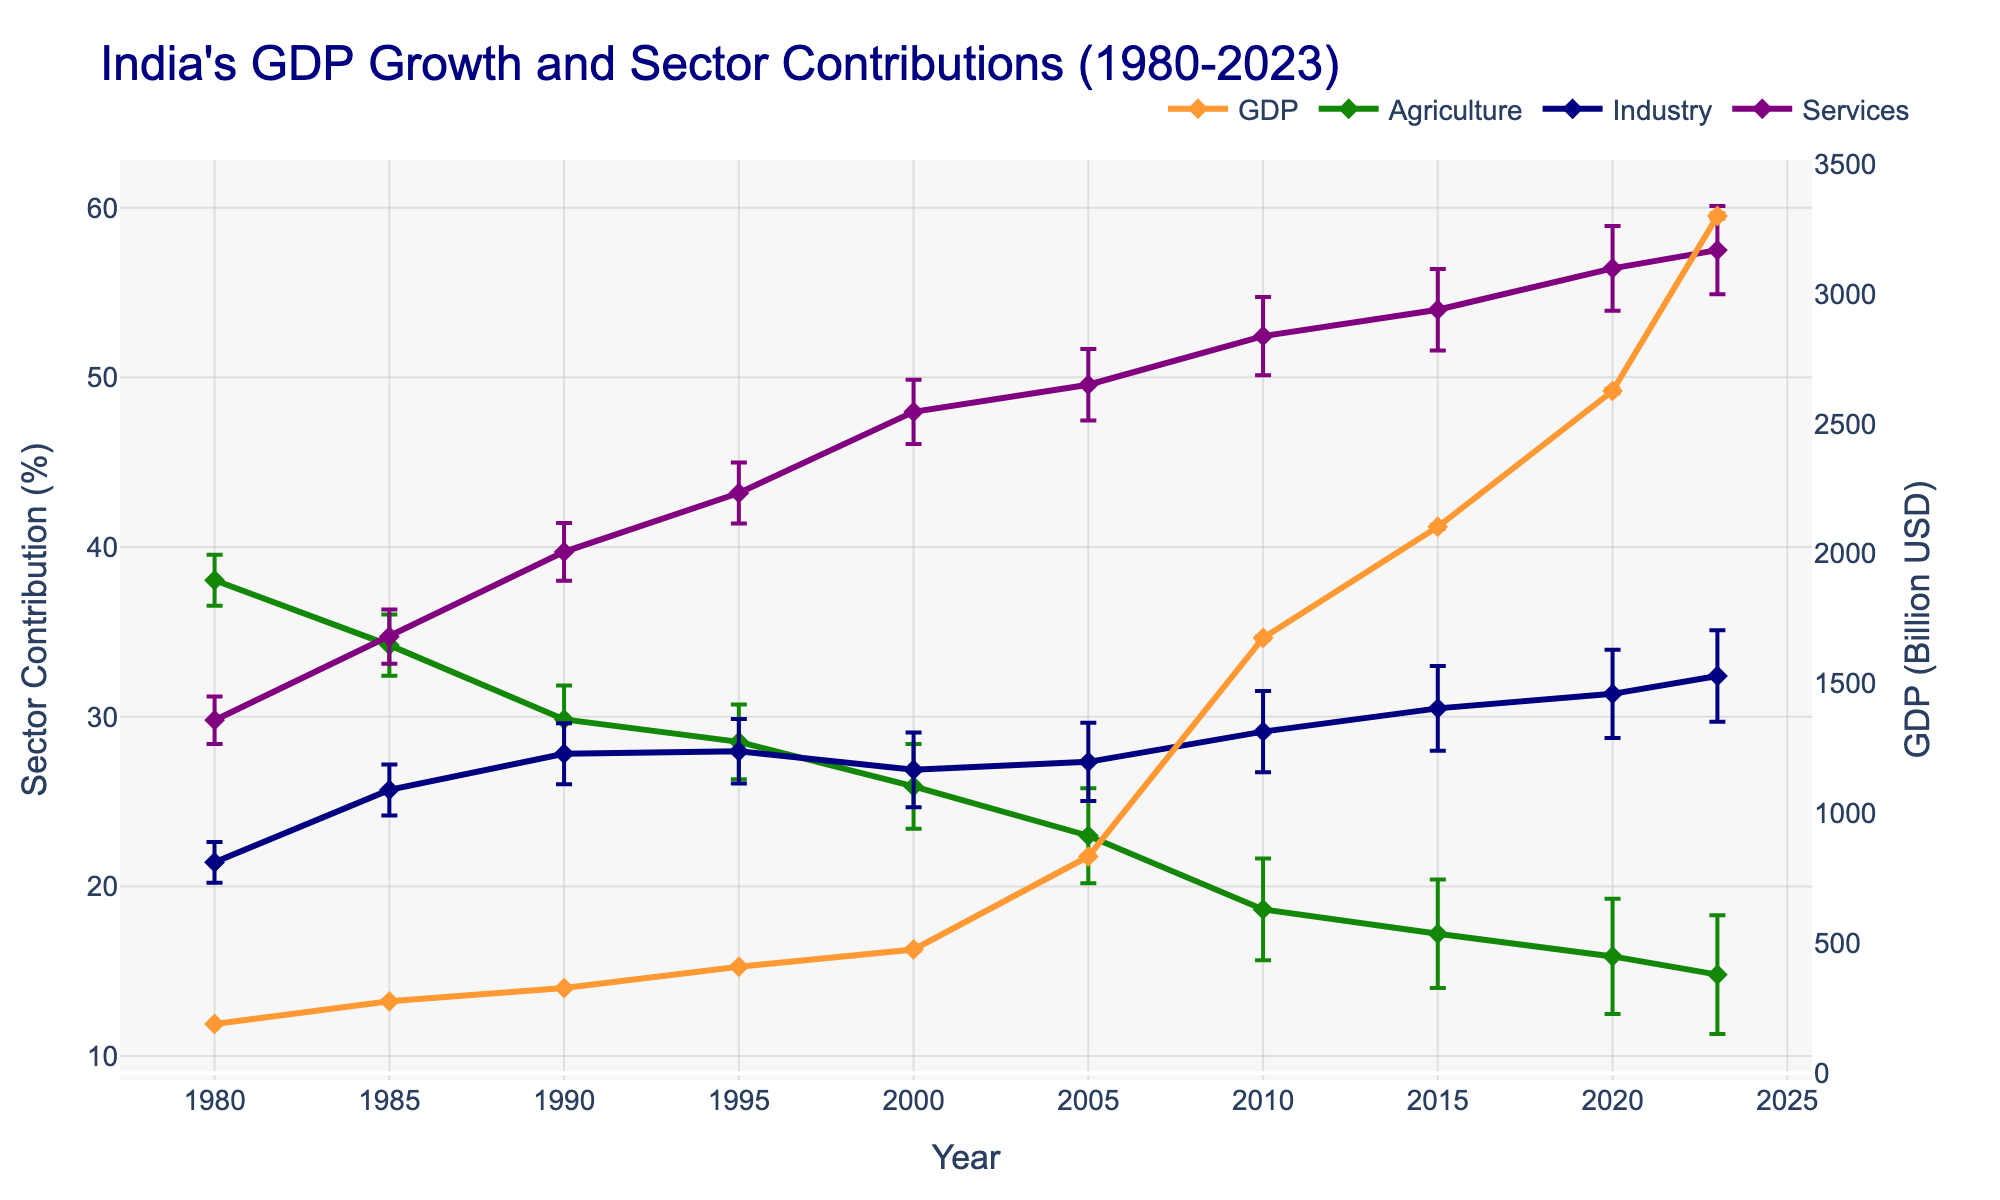what is the title of the figure? The title of the figure is found at the top and summarizes the main topic of the plot. The text reads "India's GDP Growth and Sector Contributions (1980-2023)"
Answer: India's GDP Growth and Sector Contributions (1980-2023) which sector shows the highest contribution in 2023? By looking at the position of the markers for each sector in 2023 on the X-axis, the 'Services' sector line is at the highest value on the Y-axis when compared to 'Agriculture' and 'Industry'
Answer: Services how many times does the 'Industry' sector surpass the 'Agriculture' sector in contribution over the years? Here, we compare the 'Industry' (blue line) and 'Agriculture' (green line) sector contributions for each year and note when 'Industry' has a higher value than 'Agriculture'
Answer: 9 times What is the percentage contribution of the 'Services' sector in 1995 and what is its error range? Locate the 1995 data points for the 'Services' sector on the plot. The error bars help us calculate the possible range of contribution. The value is 43.181% ± 1.8%, resulting in an error range from 41.381% to 44.981%
Answer: 43.181% (41.381% to 44.981%) How has India's GDP changed from 2000 to 2023? Find the GDP values for the years 2000 and 2023 and subtract the 2000 value from the 2023 value: 3300.000 - 476.288 = 2823.712 billion USD
Answer: 2823.712 billion USD What is the largest GDP error value, and in which year does it occur? Inspect the error bars of the GDP line plot and find the year with the largest error bar length, which is 2023 with an error value of 10.2 billion USD
Answer: 10.2 billion USD, in 2023 which sector shows the least variability in contributions over the given years? Check the range of error bars for each sector. The 'Agriculture' sector (orange) generally shows smaller error bars (between 1.5% and 3.5%) compared to other sectors. Hence, 'Agriculture' exhibits the least variability in its contribution
Answer: Agriculture During which decade did the 'Agriculture' sector experience the most significant decrease in its contribution percentage? Observe the orange line for 'Agriculture' and identify the steepest decline on the Y-axis. The drop from 1980 to 1990 (38.045% to 29.842%) stands out as the sharpest decrease in contribution
Answer: 1980-1990 how does the trend of total GDP compare to the trend of the 'Services' sector contribution? The total GDP (brown line) and the 'Services' sector (purple line) both display an upward trend over the years. This trend indicates that as GDP increased, the 'Services' sector contribution increased as well
Answer: Both show an upward trend By how much did the 'Industry' contribution increase from 1980 to 1985? Find 'Industry' sector contributions for these years, then calculate the difference: 25.685% - 21.421% = 4.264%
Answer: 4.264% 